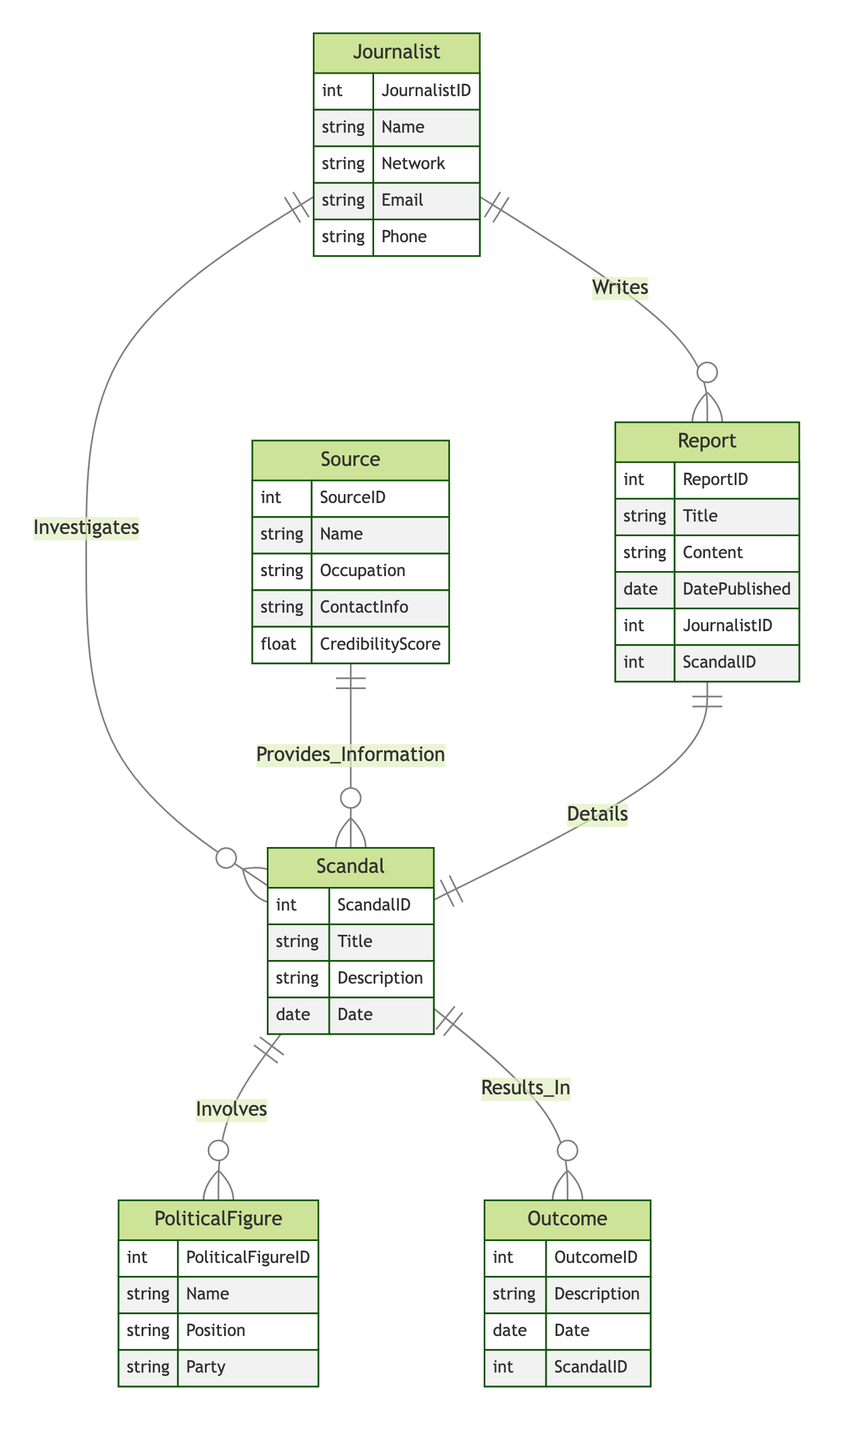What is the title of the relationship between Journalist and Report? The relationship between Journalist and Report is labeled "Writes," which indicates that a journalist can write multiple reports.
Answer: Writes How many entities are present in the diagram? The diagram lists six entities: Journalist, Source, Scandal, Report, PoliticalFigure, and Outcome. Counting them gives a total of six.
Answer: Six Which entity provides information about a scandal? The entity that provides information about a scandal is the Source, indicated by the relationship "Provides_Information."
Answer: Source What is the outcome of a scandal referred to in the diagram? The outcome of a scandal is referred to as Outcome, which describes the results generated from a scandal based on the relationship "Results_In."
Answer: Outcome How many relationships involve the Scandal entity? The Scandal entity is involved in five relationships: Investigates, Provides_Information, Involves, Results_In, and Details. Thus, the total is five.
Answer: Five Which entity involves a political figure? The entity that involves a political figure is Scandal, as shown by the relationship "Involves."
Answer: Scandal Which relationship indicates a journalist's investigation focus? The relationship indicating a journalist's investigation focus is "Investigates," which links the Journalist entity to the Scandal entity.
Answer: Investigates What is the described action of the Report entity? The Report entity is described as detailing the Scandal, as indicated by the relationship "Details."
Answer: Details What attribute represents the credibility of a source? The attribute representing the credibility of a source is "CredibilityScore," which reflects how trustworthy the source is perceived to be.
Answer: CredibilityScore 